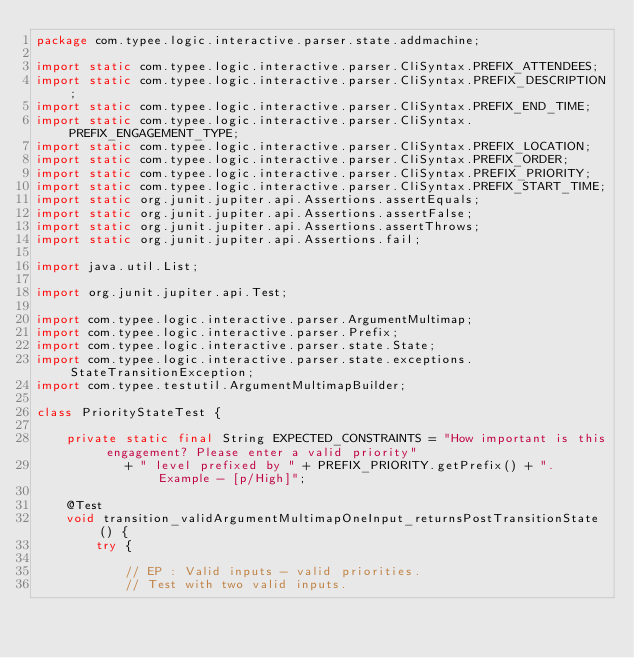<code> <loc_0><loc_0><loc_500><loc_500><_Java_>package com.typee.logic.interactive.parser.state.addmachine;

import static com.typee.logic.interactive.parser.CliSyntax.PREFIX_ATTENDEES;
import static com.typee.logic.interactive.parser.CliSyntax.PREFIX_DESCRIPTION;
import static com.typee.logic.interactive.parser.CliSyntax.PREFIX_END_TIME;
import static com.typee.logic.interactive.parser.CliSyntax.PREFIX_ENGAGEMENT_TYPE;
import static com.typee.logic.interactive.parser.CliSyntax.PREFIX_LOCATION;
import static com.typee.logic.interactive.parser.CliSyntax.PREFIX_ORDER;
import static com.typee.logic.interactive.parser.CliSyntax.PREFIX_PRIORITY;
import static com.typee.logic.interactive.parser.CliSyntax.PREFIX_START_TIME;
import static org.junit.jupiter.api.Assertions.assertEquals;
import static org.junit.jupiter.api.Assertions.assertFalse;
import static org.junit.jupiter.api.Assertions.assertThrows;
import static org.junit.jupiter.api.Assertions.fail;

import java.util.List;

import org.junit.jupiter.api.Test;

import com.typee.logic.interactive.parser.ArgumentMultimap;
import com.typee.logic.interactive.parser.Prefix;
import com.typee.logic.interactive.parser.state.State;
import com.typee.logic.interactive.parser.state.exceptions.StateTransitionException;
import com.typee.testutil.ArgumentMultimapBuilder;

class PriorityStateTest {

    private static final String EXPECTED_CONSTRAINTS = "How important is this engagement? Please enter a valid priority"
            + " level prefixed by " + PREFIX_PRIORITY.getPrefix() + ". Example - [p/High]";

    @Test
    void transition_validArgumentMultimapOneInput_returnsPostTransitionState() {
        try {

            // EP : Valid inputs - valid priorities.
            // Test with two valid inputs.
</code> 